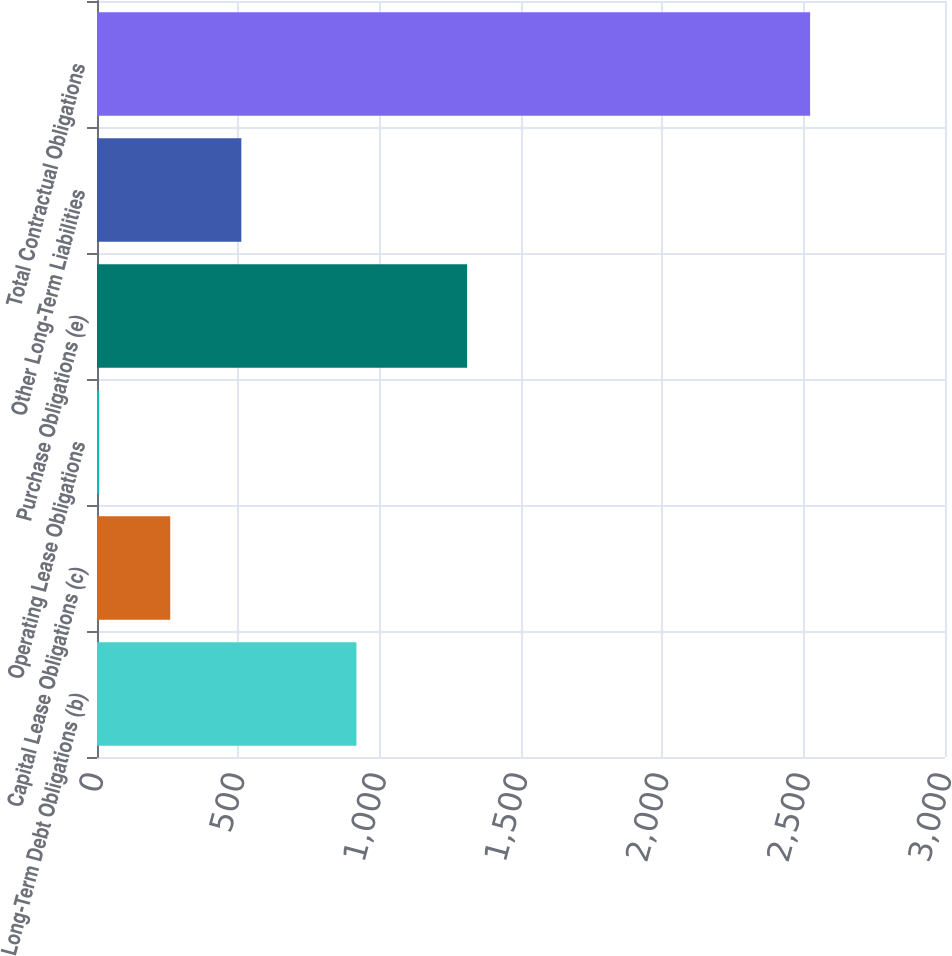<chart> <loc_0><loc_0><loc_500><loc_500><bar_chart><fcel>Long-Term Debt Obligations (b)<fcel>Capital Lease Obligations (c)<fcel>Operating Lease Obligations<fcel>Purchase Obligations (e)<fcel>Other Long-Term Liabilities<fcel>Total Contractual Obligations<nl><fcel>917.8<fcel>259.12<fcel>7.6<fcel>1309.4<fcel>510.64<fcel>2522.8<nl></chart> 